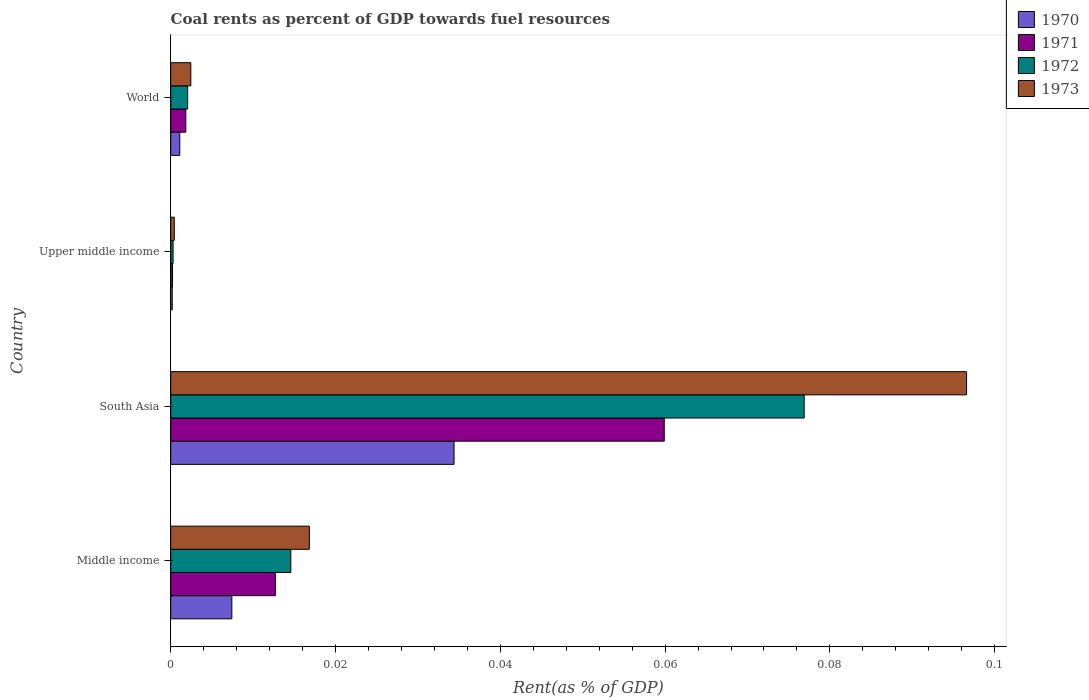How many different coloured bars are there?
Give a very brief answer. 4. How many groups of bars are there?
Your answer should be very brief. 4. Are the number of bars per tick equal to the number of legend labels?
Offer a terse response. Yes. Are the number of bars on each tick of the Y-axis equal?
Your answer should be very brief. Yes. In how many cases, is the number of bars for a given country not equal to the number of legend labels?
Offer a terse response. 0. What is the coal rent in 1971 in World?
Ensure brevity in your answer.  0. Across all countries, what is the maximum coal rent in 1970?
Your answer should be very brief. 0.03. Across all countries, what is the minimum coal rent in 1971?
Keep it short and to the point. 0. In which country was the coal rent in 1972 minimum?
Make the answer very short. Upper middle income. What is the total coal rent in 1972 in the graph?
Offer a very short reply. 0.09. What is the difference between the coal rent in 1972 in Middle income and that in Upper middle income?
Provide a short and direct response. 0.01. What is the difference between the coal rent in 1972 in World and the coal rent in 1970 in Upper middle income?
Your answer should be compact. 0. What is the average coal rent in 1971 per country?
Offer a very short reply. 0.02. What is the difference between the coal rent in 1972 and coal rent in 1971 in Middle income?
Your answer should be very brief. 0. What is the ratio of the coal rent in 1970 in South Asia to that in Upper middle income?
Give a very brief answer. 187.05. Is the coal rent in 1972 in South Asia less than that in World?
Your answer should be very brief. No. Is the difference between the coal rent in 1972 in Middle income and World greater than the difference between the coal rent in 1971 in Middle income and World?
Provide a succinct answer. Yes. What is the difference between the highest and the second highest coal rent in 1973?
Your response must be concise. 0.08. What is the difference between the highest and the lowest coal rent in 1972?
Your answer should be compact. 0.08. Is the sum of the coal rent in 1970 in Middle income and South Asia greater than the maximum coal rent in 1971 across all countries?
Your response must be concise. No. Is it the case that in every country, the sum of the coal rent in 1972 and coal rent in 1970 is greater than the sum of coal rent in 1971 and coal rent in 1973?
Your response must be concise. No. How many bars are there?
Give a very brief answer. 16. Are all the bars in the graph horizontal?
Your response must be concise. Yes. What is the difference between two consecutive major ticks on the X-axis?
Your answer should be compact. 0.02. Does the graph contain grids?
Make the answer very short. No. Where does the legend appear in the graph?
Your response must be concise. Top right. How many legend labels are there?
Offer a terse response. 4. What is the title of the graph?
Ensure brevity in your answer.  Coal rents as percent of GDP towards fuel resources. What is the label or title of the X-axis?
Provide a succinct answer. Rent(as % of GDP). What is the Rent(as % of GDP) of 1970 in Middle income?
Make the answer very short. 0.01. What is the Rent(as % of GDP) in 1971 in Middle income?
Offer a terse response. 0.01. What is the Rent(as % of GDP) in 1972 in Middle income?
Your answer should be compact. 0.01. What is the Rent(as % of GDP) in 1973 in Middle income?
Offer a terse response. 0.02. What is the Rent(as % of GDP) in 1970 in South Asia?
Provide a short and direct response. 0.03. What is the Rent(as % of GDP) of 1971 in South Asia?
Offer a very short reply. 0.06. What is the Rent(as % of GDP) in 1972 in South Asia?
Offer a very short reply. 0.08. What is the Rent(as % of GDP) in 1973 in South Asia?
Give a very brief answer. 0.1. What is the Rent(as % of GDP) of 1970 in Upper middle income?
Offer a terse response. 0. What is the Rent(as % of GDP) in 1971 in Upper middle income?
Offer a terse response. 0. What is the Rent(as % of GDP) in 1972 in Upper middle income?
Ensure brevity in your answer.  0. What is the Rent(as % of GDP) in 1973 in Upper middle income?
Your answer should be very brief. 0. What is the Rent(as % of GDP) of 1970 in World?
Your answer should be compact. 0. What is the Rent(as % of GDP) in 1971 in World?
Offer a terse response. 0. What is the Rent(as % of GDP) of 1972 in World?
Your response must be concise. 0. What is the Rent(as % of GDP) of 1973 in World?
Provide a succinct answer. 0. Across all countries, what is the maximum Rent(as % of GDP) of 1970?
Keep it short and to the point. 0.03. Across all countries, what is the maximum Rent(as % of GDP) of 1971?
Provide a short and direct response. 0.06. Across all countries, what is the maximum Rent(as % of GDP) in 1972?
Your answer should be very brief. 0.08. Across all countries, what is the maximum Rent(as % of GDP) in 1973?
Your response must be concise. 0.1. Across all countries, what is the minimum Rent(as % of GDP) of 1970?
Offer a very short reply. 0. Across all countries, what is the minimum Rent(as % of GDP) of 1971?
Your answer should be very brief. 0. Across all countries, what is the minimum Rent(as % of GDP) of 1972?
Make the answer very short. 0. Across all countries, what is the minimum Rent(as % of GDP) of 1973?
Offer a very short reply. 0. What is the total Rent(as % of GDP) of 1970 in the graph?
Ensure brevity in your answer.  0.04. What is the total Rent(as % of GDP) of 1971 in the graph?
Make the answer very short. 0.07. What is the total Rent(as % of GDP) in 1972 in the graph?
Your response must be concise. 0.09. What is the total Rent(as % of GDP) in 1973 in the graph?
Give a very brief answer. 0.12. What is the difference between the Rent(as % of GDP) of 1970 in Middle income and that in South Asia?
Make the answer very short. -0.03. What is the difference between the Rent(as % of GDP) in 1971 in Middle income and that in South Asia?
Ensure brevity in your answer.  -0.05. What is the difference between the Rent(as % of GDP) in 1972 in Middle income and that in South Asia?
Ensure brevity in your answer.  -0.06. What is the difference between the Rent(as % of GDP) in 1973 in Middle income and that in South Asia?
Offer a very short reply. -0.08. What is the difference between the Rent(as % of GDP) of 1970 in Middle income and that in Upper middle income?
Provide a short and direct response. 0.01. What is the difference between the Rent(as % of GDP) in 1971 in Middle income and that in Upper middle income?
Your response must be concise. 0.01. What is the difference between the Rent(as % of GDP) of 1972 in Middle income and that in Upper middle income?
Your answer should be compact. 0.01. What is the difference between the Rent(as % of GDP) in 1973 in Middle income and that in Upper middle income?
Offer a terse response. 0.02. What is the difference between the Rent(as % of GDP) of 1970 in Middle income and that in World?
Give a very brief answer. 0.01. What is the difference between the Rent(as % of GDP) in 1971 in Middle income and that in World?
Your answer should be compact. 0.01. What is the difference between the Rent(as % of GDP) of 1972 in Middle income and that in World?
Provide a succinct answer. 0.01. What is the difference between the Rent(as % of GDP) of 1973 in Middle income and that in World?
Ensure brevity in your answer.  0.01. What is the difference between the Rent(as % of GDP) of 1970 in South Asia and that in Upper middle income?
Offer a very short reply. 0.03. What is the difference between the Rent(as % of GDP) of 1971 in South Asia and that in Upper middle income?
Keep it short and to the point. 0.06. What is the difference between the Rent(as % of GDP) in 1972 in South Asia and that in Upper middle income?
Make the answer very short. 0.08. What is the difference between the Rent(as % of GDP) in 1973 in South Asia and that in Upper middle income?
Your answer should be very brief. 0.1. What is the difference between the Rent(as % of GDP) of 1970 in South Asia and that in World?
Make the answer very short. 0.03. What is the difference between the Rent(as % of GDP) of 1971 in South Asia and that in World?
Your response must be concise. 0.06. What is the difference between the Rent(as % of GDP) of 1972 in South Asia and that in World?
Give a very brief answer. 0.07. What is the difference between the Rent(as % of GDP) in 1973 in South Asia and that in World?
Keep it short and to the point. 0.09. What is the difference between the Rent(as % of GDP) in 1970 in Upper middle income and that in World?
Make the answer very short. -0. What is the difference between the Rent(as % of GDP) of 1971 in Upper middle income and that in World?
Keep it short and to the point. -0. What is the difference between the Rent(as % of GDP) of 1972 in Upper middle income and that in World?
Offer a very short reply. -0. What is the difference between the Rent(as % of GDP) in 1973 in Upper middle income and that in World?
Give a very brief answer. -0. What is the difference between the Rent(as % of GDP) of 1970 in Middle income and the Rent(as % of GDP) of 1971 in South Asia?
Provide a short and direct response. -0.05. What is the difference between the Rent(as % of GDP) in 1970 in Middle income and the Rent(as % of GDP) in 1972 in South Asia?
Your answer should be very brief. -0.07. What is the difference between the Rent(as % of GDP) in 1970 in Middle income and the Rent(as % of GDP) in 1973 in South Asia?
Give a very brief answer. -0.09. What is the difference between the Rent(as % of GDP) of 1971 in Middle income and the Rent(as % of GDP) of 1972 in South Asia?
Offer a very short reply. -0.06. What is the difference between the Rent(as % of GDP) of 1971 in Middle income and the Rent(as % of GDP) of 1973 in South Asia?
Keep it short and to the point. -0.08. What is the difference between the Rent(as % of GDP) in 1972 in Middle income and the Rent(as % of GDP) in 1973 in South Asia?
Provide a succinct answer. -0.08. What is the difference between the Rent(as % of GDP) of 1970 in Middle income and the Rent(as % of GDP) of 1971 in Upper middle income?
Provide a short and direct response. 0.01. What is the difference between the Rent(as % of GDP) in 1970 in Middle income and the Rent(as % of GDP) in 1972 in Upper middle income?
Give a very brief answer. 0.01. What is the difference between the Rent(as % of GDP) in 1970 in Middle income and the Rent(as % of GDP) in 1973 in Upper middle income?
Your response must be concise. 0.01. What is the difference between the Rent(as % of GDP) of 1971 in Middle income and the Rent(as % of GDP) of 1972 in Upper middle income?
Make the answer very short. 0.01. What is the difference between the Rent(as % of GDP) in 1971 in Middle income and the Rent(as % of GDP) in 1973 in Upper middle income?
Give a very brief answer. 0.01. What is the difference between the Rent(as % of GDP) in 1972 in Middle income and the Rent(as % of GDP) in 1973 in Upper middle income?
Ensure brevity in your answer.  0.01. What is the difference between the Rent(as % of GDP) in 1970 in Middle income and the Rent(as % of GDP) in 1971 in World?
Give a very brief answer. 0.01. What is the difference between the Rent(as % of GDP) in 1970 in Middle income and the Rent(as % of GDP) in 1972 in World?
Ensure brevity in your answer.  0.01. What is the difference between the Rent(as % of GDP) of 1970 in Middle income and the Rent(as % of GDP) of 1973 in World?
Offer a very short reply. 0.01. What is the difference between the Rent(as % of GDP) in 1971 in Middle income and the Rent(as % of GDP) in 1972 in World?
Offer a terse response. 0.01. What is the difference between the Rent(as % of GDP) in 1971 in Middle income and the Rent(as % of GDP) in 1973 in World?
Provide a short and direct response. 0.01. What is the difference between the Rent(as % of GDP) of 1972 in Middle income and the Rent(as % of GDP) of 1973 in World?
Provide a succinct answer. 0.01. What is the difference between the Rent(as % of GDP) of 1970 in South Asia and the Rent(as % of GDP) of 1971 in Upper middle income?
Offer a very short reply. 0.03. What is the difference between the Rent(as % of GDP) in 1970 in South Asia and the Rent(as % of GDP) in 1972 in Upper middle income?
Keep it short and to the point. 0.03. What is the difference between the Rent(as % of GDP) of 1970 in South Asia and the Rent(as % of GDP) of 1973 in Upper middle income?
Make the answer very short. 0.03. What is the difference between the Rent(as % of GDP) of 1971 in South Asia and the Rent(as % of GDP) of 1972 in Upper middle income?
Offer a very short reply. 0.06. What is the difference between the Rent(as % of GDP) of 1971 in South Asia and the Rent(as % of GDP) of 1973 in Upper middle income?
Offer a terse response. 0.06. What is the difference between the Rent(as % of GDP) of 1972 in South Asia and the Rent(as % of GDP) of 1973 in Upper middle income?
Provide a short and direct response. 0.08. What is the difference between the Rent(as % of GDP) in 1970 in South Asia and the Rent(as % of GDP) in 1971 in World?
Provide a succinct answer. 0.03. What is the difference between the Rent(as % of GDP) in 1970 in South Asia and the Rent(as % of GDP) in 1972 in World?
Make the answer very short. 0.03. What is the difference between the Rent(as % of GDP) of 1970 in South Asia and the Rent(as % of GDP) of 1973 in World?
Offer a terse response. 0.03. What is the difference between the Rent(as % of GDP) in 1971 in South Asia and the Rent(as % of GDP) in 1972 in World?
Your response must be concise. 0.06. What is the difference between the Rent(as % of GDP) of 1971 in South Asia and the Rent(as % of GDP) of 1973 in World?
Give a very brief answer. 0.06. What is the difference between the Rent(as % of GDP) of 1972 in South Asia and the Rent(as % of GDP) of 1973 in World?
Your answer should be very brief. 0.07. What is the difference between the Rent(as % of GDP) in 1970 in Upper middle income and the Rent(as % of GDP) in 1971 in World?
Provide a succinct answer. -0. What is the difference between the Rent(as % of GDP) in 1970 in Upper middle income and the Rent(as % of GDP) in 1972 in World?
Your answer should be very brief. -0. What is the difference between the Rent(as % of GDP) in 1970 in Upper middle income and the Rent(as % of GDP) in 1973 in World?
Provide a succinct answer. -0. What is the difference between the Rent(as % of GDP) of 1971 in Upper middle income and the Rent(as % of GDP) of 1972 in World?
Your response must be concise. -0. What is the difference between the Rent(as % of GDP) of 1971 in Upper middle income and the Rent(as % of GDP) of 1973 in World?
Offer a terse response. -0. What is the difference between the Rent(as % of GDP) of 1972 in Upper middle income and the Rent(as % of GDP) of 1973 in World?
Give a very brief answer. -0. What is the average Rent(as % of GDP) of 1970 per country?
Make the answer very short. 0.01. What is the average Rent(as % of GDP) in 1971 per country?
Offer a very short reply. 0.02. What is the average Rent(as % of GDP) in 1972 per country?
Your answer should be compact. 0.02. What is the average Rent(as % of GDP) in 1973 per country?
Offer a very short reply. 0.03. What is the difference between the Rent(as % of GDP) in 1970 and Rent(as % of GDP) in 1971 in Middle income?
Your response must be concise. -0.01. What is the difference between the Rent(as % of GDP) in 1970 and Rent(as % of GDP) in 1972 in Middle income?
Your response must be concise. -0.01. What is the difference between the Rent(as % of GDP) in 1970 and Rent(as % of GDP) in 1973 in Middle income?
Your answer should be very brief. -0.01. What is the difference between the Rent(as % of GDP) in 1971 and Rent(as % of GDP) in 1972 in Middle income?
Give a very brief answer. -0. What is the difference between the Rent(as % of GDP) in 1971 and Rent(as % of GDP) in 1973 in Middle income?
Provide a short and direct response. -0. What is the difference between the Rent(as % of GDP) in 1972 and Rent(as % of GDP) in 1973 in Middle income?
Give a very brief answer. -0. What is the difference between the Rent(as % of GDP) in 1970 and Rent(as % of GDP) in 1971 in South Asia?
Your answer should be compact. -0.03. What is the difference between the Rent(as % of GDP) of 1970 and Rent(as % of GDP) of 1972 in South Asia?
Offer a very short reply. -0.04. What is the difference between the Rent(as % of GDP) of 1970 and Rent(as % of GDP) of 1973 in South Asia?
Offer a very short reply. -0.06. What is the difference between the Rent(as % of GDP) in 1971 and Rent(as % of GDP) in 1972 in South Asia?
Keep it short and to the point. -0.02. What is the difference between the Rent(as % of GDP) of 1971 and Rent(as % of GDP) of 1973 in South Asia?
Offer a terse response. -0.04. What is the difference between the Rent(as % of GDP) in 1972 and Rent(as % of GDP) in 1973 in South Asia?
Your response must be concise. -0.02. What is the difference between the Rent(as % of GDP) in 1970 and Rent(as % of GDP) in 1972 in Upper middle income?
Provide a succinct answer. -0. What is the difference between the Rent(as % of GDP) of 1970 and Rent(as % of GDP) of 1973 in Upper middle income?
Offer a terse response. -0. What is the difference between the Rent(as % of GDP) in 1971 and Rent(as % of GDP) in 1972 in Upper middle income?
Ensure brevity in your answer.  -0. What is the difference between the Rent(as % of GDP) in 1971 and Rent(as % of GDP) in 1973 in Upper middle income?
Make the answer very short. -0. What is the difference between the Rent(as % of GDP) of 1972 and Rent(as % of GDP) of 1973 in Upper middle income?
Your answer should be very brief. -0. What is the difference between the Rent(as % of GDP) of 1970 and Rent(as % of GDP) of 1971 in World?
Provide a succinct answer. -0. What is the difference between the Rent(as % of GDP) of 1970 and Rent(as % of GDP) of 1972 in World?
Ensure brevity in your answer.  -0. What is the difference between the Rent(as % of GDP) in 1970 and Rent(as % of GDP) in 1973 in World?
Make the answer very short. -0. What is the difference between the Rent(as % of GDP) in 1971 and Rent(as % of GDP) in 1972 in World?
Provide a succinct answer. -0. What is the difference between the Rent(as % of GDP) of 1971 and Rent(as % of GDP) of 1973 in World?
Provide a short and direct response. -0. What is the difference between the Rent(as % of GDP) of 1972 and Rent(as % of GDP) of 1973 in World?
Your answer should be compact. -0. What is the ratio of the Rent(as % of GDP) of 1970 in Middle income to that in South Asia?
Provide a short and direct response. 0.22. What is the ratio of the Rent(as % of GDP) of 1971 in Middle income to that in South Asia?
Provide a succinct answer. 0.21. What is the ratio of the Rent(as % of GDP) in 1972 in Middle income to that in South Asia?
Provide a succinct answer. 0.19. What is the ratio of the Rent(as % of GDP) of 1973 in Middle income to that in South Asia?
Your response must be concise. 0.17. What is the ratio of the Rent(as % of GDP) in 1970 in Middle income to that in Upper middle income?
Ensure brevity in your answer.  40.36. What is the ratio of the Rent(as % of GDP) in 1971 in Middle income to that in Upper middle income?
Offer a terse response. 58.01. What is the ratio of the Rent(as % of GDP) of 1972 in Middle income to that in Upper middle income?
Offer a terse response. 51.25. What is the ratio of the Rent(as % of GDP) of 1973 in Middle income to that in Upper middle income?
Provide a succinct answer. 39.04. What is the ratio of the Rent(as % of GDP) in 1970 in Middle income to that in World?
Keep it short and to the point. 6.74. What is the ratio of the Rent(as % of GDP) in 1971 in Middle income to that in World?
Make the answer very short. 6.93. What is the ratio of the Rent(as % of GDP) of 1972 in Middle income to that in World?
Offer a terse response. 7.09. What is the ratio of the Rent(as % of GDP) of 1973 in Middle income to that in World?
Give a very brief answer. 6.91. What is the ratio of the Rent(as % of GDP) in 1970 in South Asia to that in Upper middle income?
Provide a succinct answer. 187.05. What is the ratio of the Rent(as % of GDP) in 1971 in South Asia to that in Upper middle income?
Make the answer very short. 273.74. What is the ratio of the Rent(as % of GDP) of 1972 in South Asia to that in Upper middle income?
Keep it short and to the point. 270.32. What is the ratio of the Rent(as % of GDP) in 1973 in South Asia to that in Upper middle income?
Provide a short and direct response. 224.18. What is the ratio of the Rent(as % of GDP) of 1970 in South Asia to that in World?
Provide a succinct answer. 31.24. What is the ratio of the Rent(as % of GDP) of 1971 in South Asia to that in World?
Your response must be concise. 32.69. What is the ratio of the Rent(as % of GDP) of 1972 in South Asia to that in World?
Offer a terse response. 37.41. What is the ratio of the Rent(as % of GDP) in 1973 in South Asia to that in World?
Ensure brevity in your answer.  39.65. What is the ratio of the Rent(as % of GDP) of 1970 in Upper middle income to that in World?
Provide a short and direct response. 0.17. What is the ratio of the Rent(as % of GDP) of 1971 in Upper middle income to that in World?
Keep it short and to the point. 0.12. What is the ratio of the Rent(as % of GDP) in 1972 in Upper middle income to that in World?
Offer a terse response. 0.14. What is the ratio of the Rent(as % of GDP) of 1973 in Upper middle income to that in World?
Provide a succinct answer. 0.18. What is the difference between the highest and the second highest Rent(as % of GDP) of 1970?
Provide a succinct answer. 0.03. What is the difference between the highest and the second highest Rent(as % of GDP) of 1971?
Your answer should be very brief. 0.05. What is the difference between the highest and the second highest Rent(as % of GDP) of 1972?
Offer a very short reply. 0.06. What is the difference between the highest and the second highest Rent(as % of GDP) in 1973?
Your answer should be very brief. 0.08. What is the difference between the highest and the lowest Rent(as % of GDP) in 1970?
Offer a terse response. 0.03. What is the difference between the highest and the lowest Rent(as % of GDP) in 1971?
Offer a very short reply. 0.06. What is the difference between the highest and the lowest Rent(as % of GDP) in 1972?
Your response must be concise. 0.08. What is the difference between the highest and the lowest Rent(as % of GDP) of 1973?
Ensure brevity in your answer.  0.1. 